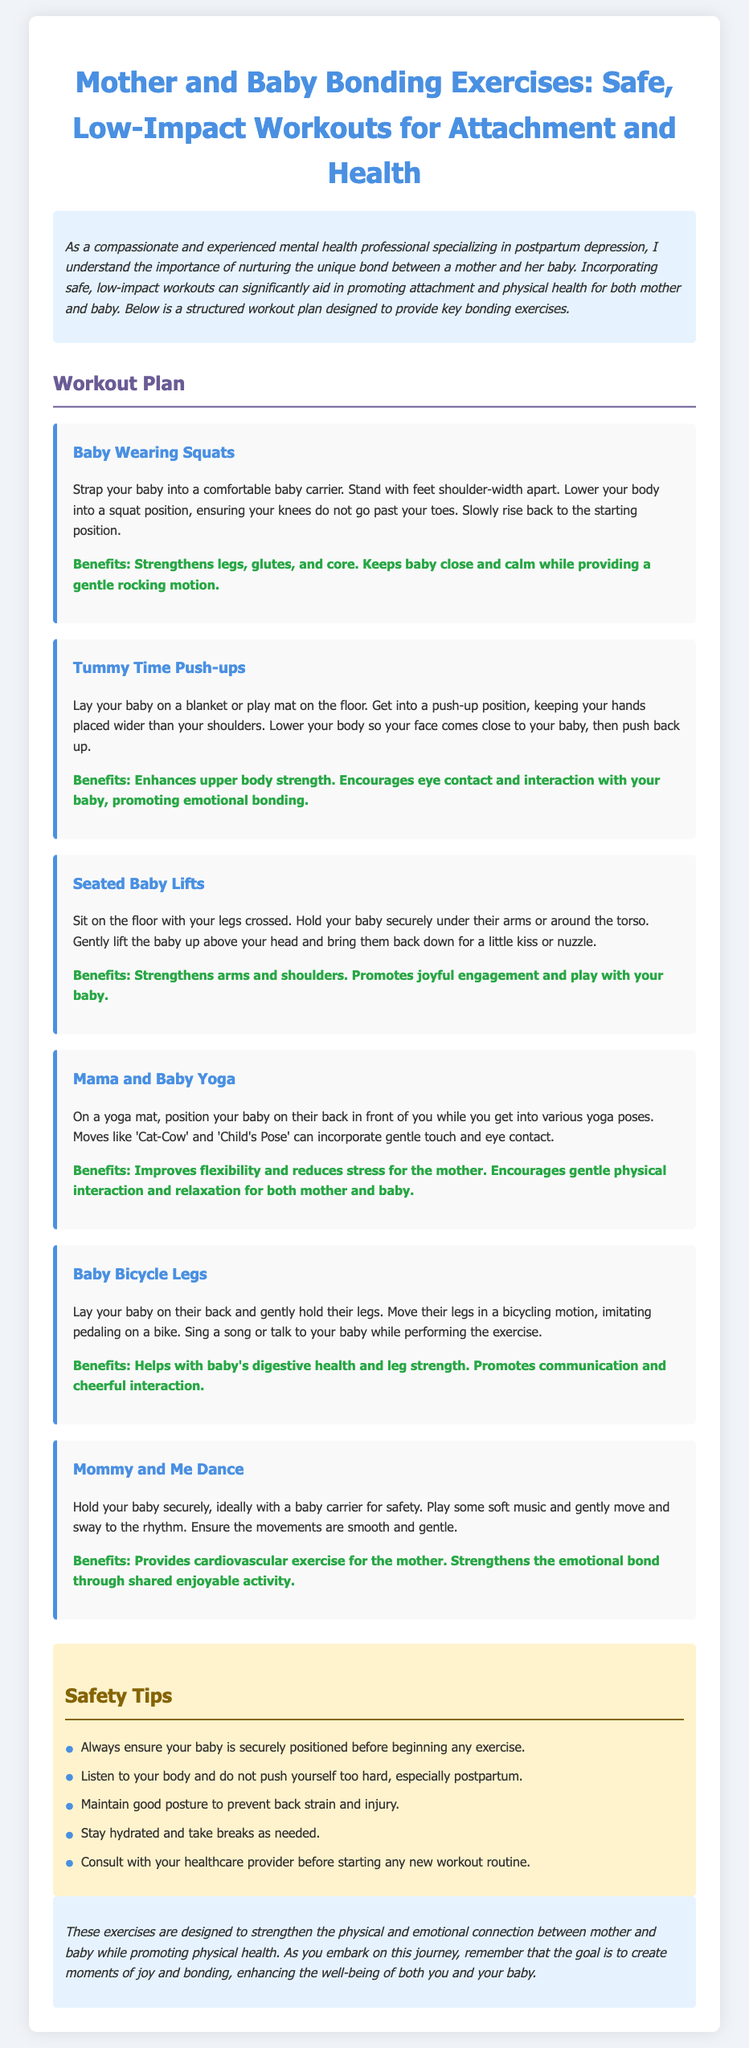What is the title of the document? The title of the document, as stated in the header, is the main subject focused on mother and baby bonding exercises.
Answer: Mother and Baby Bonding Exercises: Safe, Low-Impact Workouts for Attachment and Health How many exercises are listed in the workout plan? The document lists a total of six bonding exercises that mothers can perform with their babies.
Answer: Six What is one benefit of the "Baby Wearing Squats"? The listed benefits highlight the advantages of the exercise, particularly for mothers and their babies.
Answer: Strengthens legs, glutes, and core What should be used to secure a baby in "Mommy and Me Dance"? This detail emphasizes safety when performing the exercise with the baby.
Answer: Baby carrier Which exercise promotes emotional bonding through face-to-face interaction? The question focuses on an exercise that encourages direct engagement between mother and baby.
Answer: Tummy Time Push-ups What is one safety tip mentioned in the document? This question seeks to extract important safety precautions provided within the document.
Answer: Always ensure your baby is securely positioned before beginning any exercise 